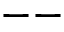<formula> <loc_0><loc_0><loc_500><loc_500>- -</formula> 